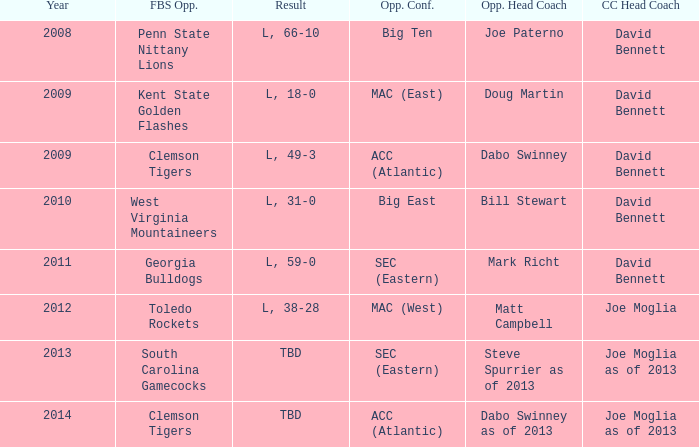Could you parse the entire table as a dict? {'header': ['Year', 'FBS Opp.', 'Result', 'Opp. Conf.', 'Opp. Head Coach', 'CC Head Coach'], 'rows': [['2008', 'Penn State Nittany Lions', 'L, 66-10', 'Big Ten', 'Joe Paterno', 'David Bennett'], ['2009', 'Kent State Golden Flashes', 'L, 18-0', 'MAC (East)', 'Doug Martin', 'David Bennett'], ['2009', 'Clemson Tigers', 'L, 49-3', 'ACC (Atlantic)', 'Dabo Swinney', 'David Bennett'], ['2010', 'West Virginia Mountaineers', 'L, 31-0', 'Big East', 'Bill Stewart', 'David Bennett'], ['2011', 'Georgia Bulldogs', 'L, 59-0', 'SEC (Eastern)', 'Mark Richt', 'David Bennett'], ['2012', 'Toledo Rockets', 'L, 38-28', 'MAC (West)', 'Matt Campbell', 'Joe Moglia'], ['2013', 'South Carolina Gamecocks', 'TBD', 'SEC (Eastern)', 'Steve Spurrier as of 2013', 'Joe Moglia as of 2013'], ['2014', 'Clemson Tigers', 'TBD', 'ACC (Atlantic)', 'Dabo Swinney as of 2013', 'Joe Moglia as of 2013']]} How many head coaches did Kent state golden flashes have? 1.0. 